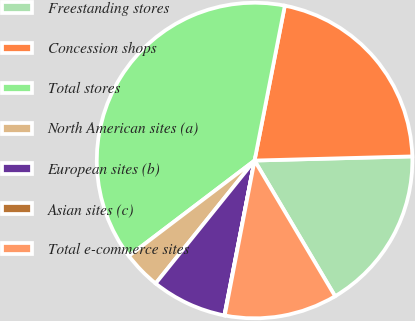Convert chart. <chart><loc_0><loc_0><loc_500><loc_500><pie_chart><fcel>Freestanding stores<fcel>Concession shops<fcel>Total stores<fcel>North American sites (a)<fcel>European sites (b)<fcel>Asian sites (c)<fcel>Total e-commerce sites<nl><fcel>16.89%<fcel>21.51%<fcel>38.4%<fcel>3.88%<fcel>7.72%<fcel>0.04%<fcel>11.55%<nl></chart> 